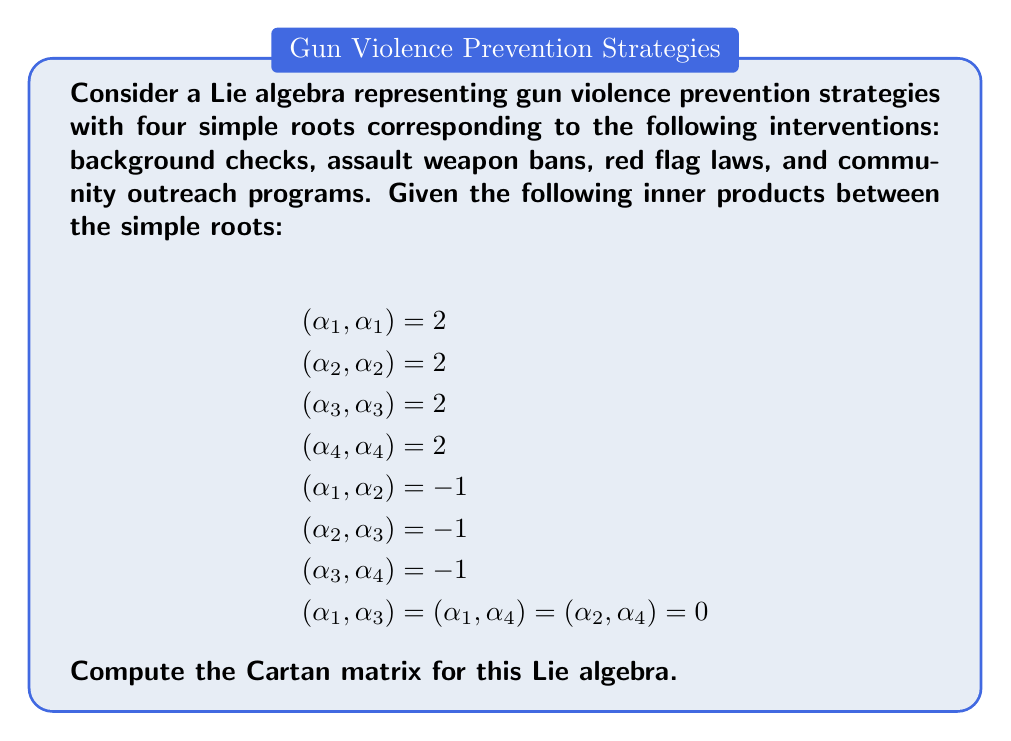Can you solve this math problem? To compute the Cartan matrix for this Lie algebra, we need to follow these steps:

1) Recall that the Cartan matrix $A = (a_{ij})$ is defined by:

   $a_{ij} = \frac{2(\alpha_i, \alpha_j)}{(\alpha_j, \alpha_j)}$

   where $\alpha_i$ and $\alpha_j$ are simple roots.

2) Given that all simple roots have the same length (as $(\alpha_i, \alpha_i) = 2$ for all $i$), we can simplify our calculation to:

   $a_{ij} = (\alpha_i, \alpha_j)$

3) Now, let's fill in the Cartan matrix:

   - Diagonal elements: $a_{ii} = (\alpha_i, \alpha_i) = 2$ for all $i$
   
   - Off-diagonal elements:
     $a_{12} = a_{21} = (\alpha_1, \alpha_2) = -1$
     $a_{23} = a_{32} = (\alpha_2, \alpha_3) = -1$
     $a_{34} = a_{43} = (\alpha_3, \alpha_4) = -1$
     
     All other off-diagonal elements are 0 as given in the problem.

4) Therefore, the Cartan matrix is:

   $$A = \begin{pmatrix}
   2 & -1 & 0 & 0 \\
   -1 & 2 & -1 & 0 \\
   0 & -1 & 2 & -1 \\
   0 & 0 & -1 & 2
   \end{pmatrix}$$

This Cartan matrix corresponds to the Lie algebra of type $A_4$, which is associated with the special linear group $SL(5)$.
Answer: $$A = \begin{pmatrix}
2 & -1 & 0 & 0 \\
-1 & 2 & -1 & 0 \\
0 & -1 & 2 & -1 \\
0 & 0 & -1 & 2
\end{pmatrix}$$ 